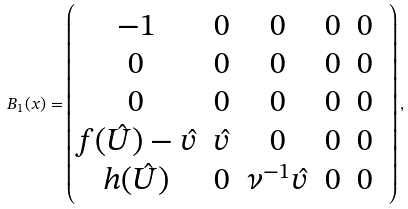<formula> <loc_0><loc_0><loc_500><loc_500>B _ { 1 } ( x ) = \begin{pmatrix} - 1 & 0 & 0 & 0 & 0 \\ 0 & 0 & 0 & 0 & 0 \\ 0 & 0 & 0 & 0 & 0 \\ f ( \hat { U } ) - \hat { v } & \hat { v } & 0 & 0 & 0 \\ h ( \hat { U } ) & 0 & \nu ^ { - 1 } \hat { v } & 0 & 0 & \\ \end{pmatrix} ,</formula> 